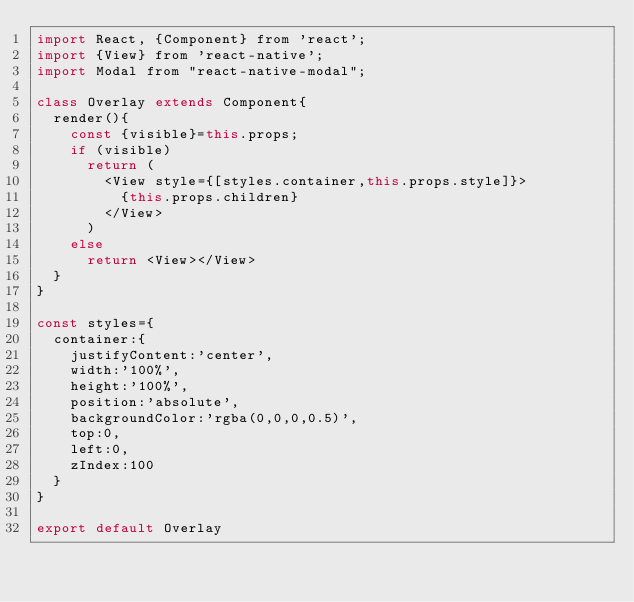<code> <loc_0><loc_0><loc_500><loc_500><_JavaScript_>import React, {Component} from 'react';
import {View} from 'react-native';
import Modal from "react-native-modal";

class Overlay extends Component{
	render(){
		const {visible}=this.props;
		if (visible)
			return (
				<View style={[styles.container,this.props.style]}>
					{this.props.children}
				</View>
			)
		else
			return <View></View>
	}
}

const styles={
	container:{
		justifyContent:'center',
		width:'100%',
		height:'100%',
		position:'absolute',
		backgroundColor:'rgba(0,0,0,0.5)',
		top:0,
		left:0,
		zIndex:100
	}
}

export default Overlay</code> 